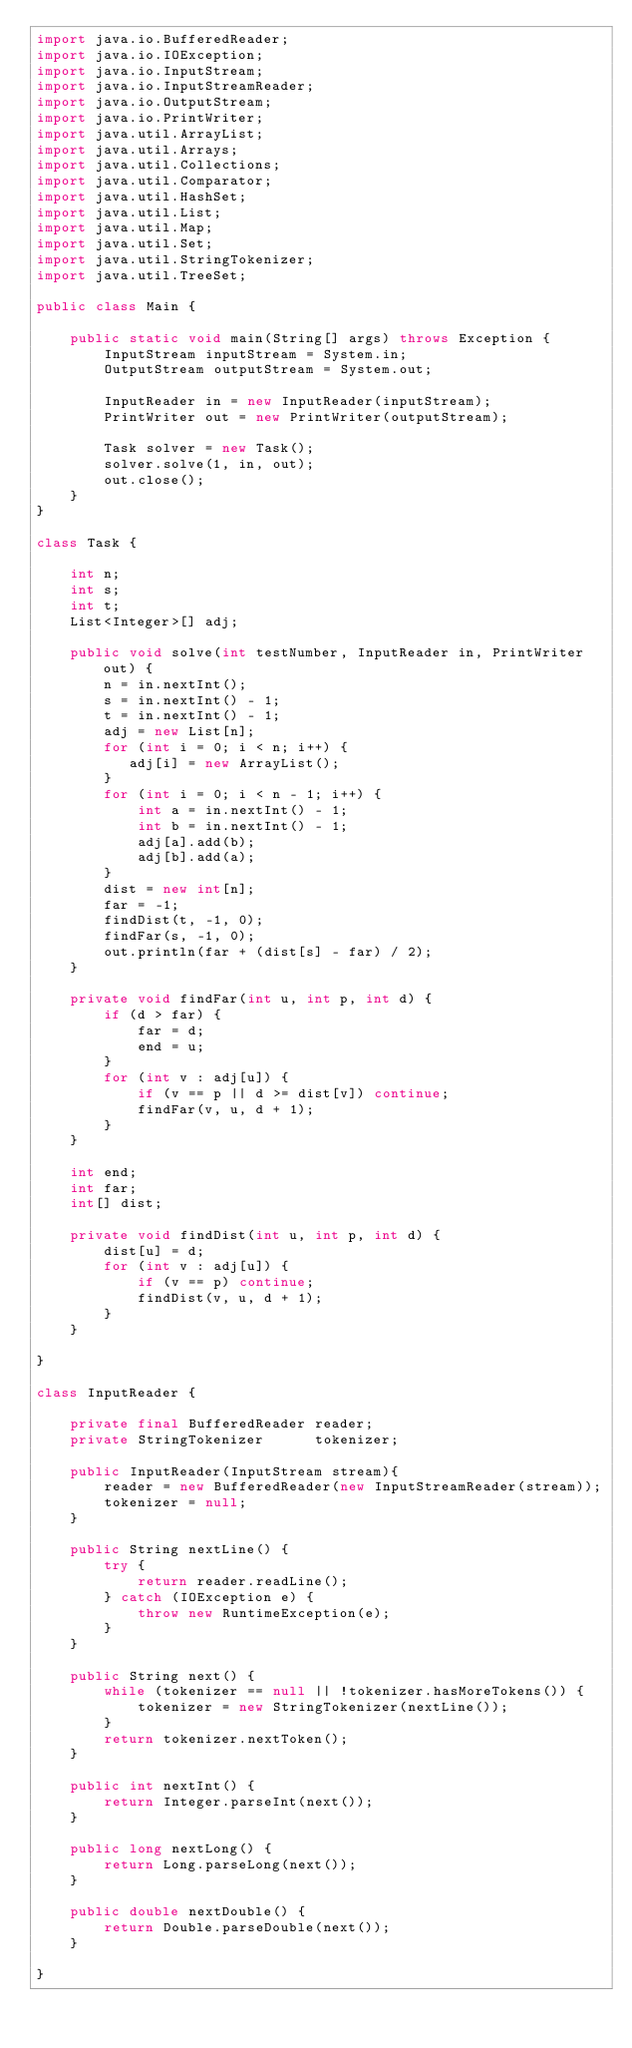Convert code to text. <code><loc_0><loc_0><loc_500><loc_500><_Java_>import java.io.BufferedReader;
import java.io.IOException;
import java.io.InputStream;
import java.io.InputStreamReader;
import java.io.OutputStream;
import java.io.PrintWriter;
import java.util.ArrayList;
import java.util.Arrays;
import java.util.Collections;
import java.util.Comparator;
import java.util.HashSet;
import java.util.List;
import java.util.Map;
import java.util.Set;
import java.util.StringTokenizer;
import java.util.TreeSet;

public class Main {

    public static void main(String[] args) throws Exception {
        InputStream inputStream = System.in;
        OutputStream outputStream = System.out;

        InputReader in = new InputReader(inputStream);
        PrintWriter out = new PrintWriter(outputStream);

        Task solver = new Task();
        solver.solve(1, in, out);
        out.close();
    }
}

class Task {

    int n;
    int s;
    int t;
    List<Integer>[] adj;

    public void solve(int testNumber, InputReader in, PrintWriter out) {
        n = in.nextInt();
        s = in.nextInt() - 1;
        t = in.nextInt() - 1;
        adj = new List[n];
        for (int i = 0; i < n; i++) {
           adj[i] = new ArrayList();
        }
        for (int i = 0; i < n - 1; i++) {
            int a = in.nextInt() - 1;
            int b = in.nextInt() - 1;
            adj[a].add(b);
            adj[b].add(a);
        }
        dist = new int[n];
        far = -1;
        findDist(t, -1, 0);
        findFar(s, -1, 0);
        out.println(far + (dist[s] - far) / 2);
    }

    private void findFar(int u, int p, int d) {
        if (d > far) {
            far = d;
            end = u;
        }
        for (int v : adj[u]) {
            if (v == p || d >= dist[v]) continue;
            findFar(v, u, d + 1);
        }
    }

    int end;
    int far;
    int[] dist;

    private void findDist(int u, int p, int d) {
        dist[u] = d;
        for (int v : adj[u]) {
            if (v == p) continue;
            findDist(v, u, d + 1);
        }
    }

}

class InputReader {

    private final BufferedReader reader;
    private StringTokenizer      tokenizer;

    public InputReader(InputStream stream){
        reader = new BufferedReader(new InputStreamReader(stream));
        tokenizer = null;
    }

    public String nextLine() {
        try {
            return reader.readLine();
        } catch (IOException e) {
            throw new RuntimeException(e);
        }
    }

    public String next() {
        while (tokenizer == null || !tokenizer.hasMoreTokens()) {
            tokenizer = new StringTokenizer(nextLine());
        }
        return tokenizer.nextToken();
    }

    public int nextInt() {
        return Integer.parseInt(next());
    }

    public long nextLong() {
        return Long.parseLong(next());
    }

    public double nextDouble() {
        return Double.parseDouble(next());
    }

}
</code> 